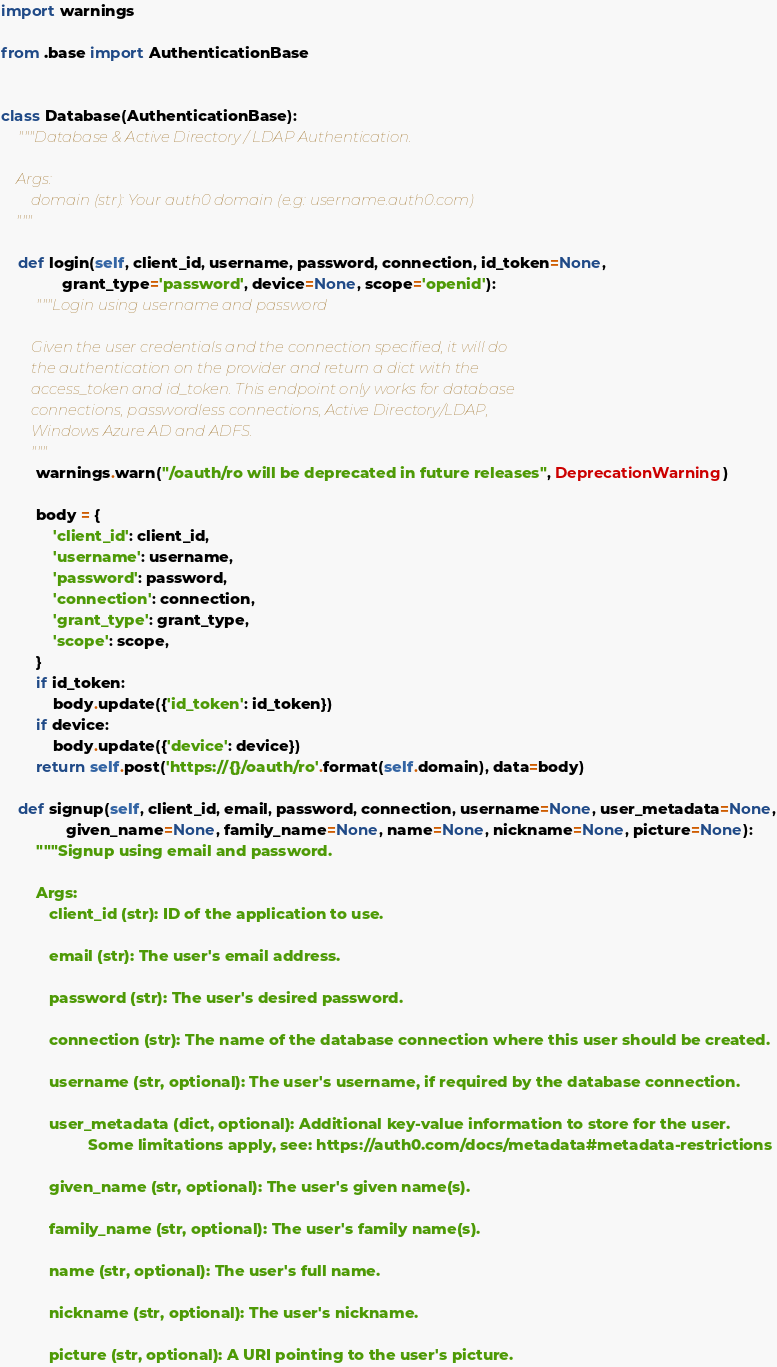<code> <loc_0><loc_0><loc_500><loc_500><_Python_>import warnings

from .base import AuthenticationBase


class Database(AuthenticationBase):
    """Database & Active Directory / LDAP Authentication.

    Args:
        domain (str): Your auth0 domain (e.g: username.auth0.com)
    """

    def login(self, client_id, username, password, connection, id_token=None,
              grant_type='password', device=None, scope='openid'):
        """Login using username and password

        Given the user credentials and the connection specified, it will do
        the authentication on the provider and return a dict with the
        access_token and id_token. This endpoint only works for database
        connections, passwordless connections, Active Directory/LDAP,
        Windows Azure AD and ADFS.
        """
        warnings.warn("/oauth/ro will be deprecated in future releases", DeprecationWarning)

        body = {
            'client_id': client_id,
            'username': username,
            'password': password,
            'connection': connection,
            'grant_type': grant_type,
            'scope': scope,
        }
        if id_token:
            body.update({'id_token': id_token})
        if device:
            body.update({'device': device})
        return self.post('https://{}/oauth/ro'.format(self.domain), data=body)

    def signup(self, client_id, email, password, connection, username=None, user_metadata=None,
               given_name=None, family_name=None, name=None, nickname=None, picture=None):
        """Signup using email and password.

        Args:
           client_id (str): ID of the application to use.

           email (str): The user's email address.

           password (str): The user's desired password.

           connection (str): The name of the database connection where this user should be created.

           username (str, optional): The user's username, if required by the database connection.

           user_metadata (dict, optional): Additional key-value information to store for the user.
                    Some limitations apply, see: https://auth0.com/docs/metadata#metadata-restrictions

           given_name (str, optional): The user's given name(s).

           family_name (str, optional): The user's family name(s).

           name (str, optional): The user's full name.

           nickname (str, optional): The user's nickname.

           picture (str, optional): A URI pointing to the user's picture.

</code> 